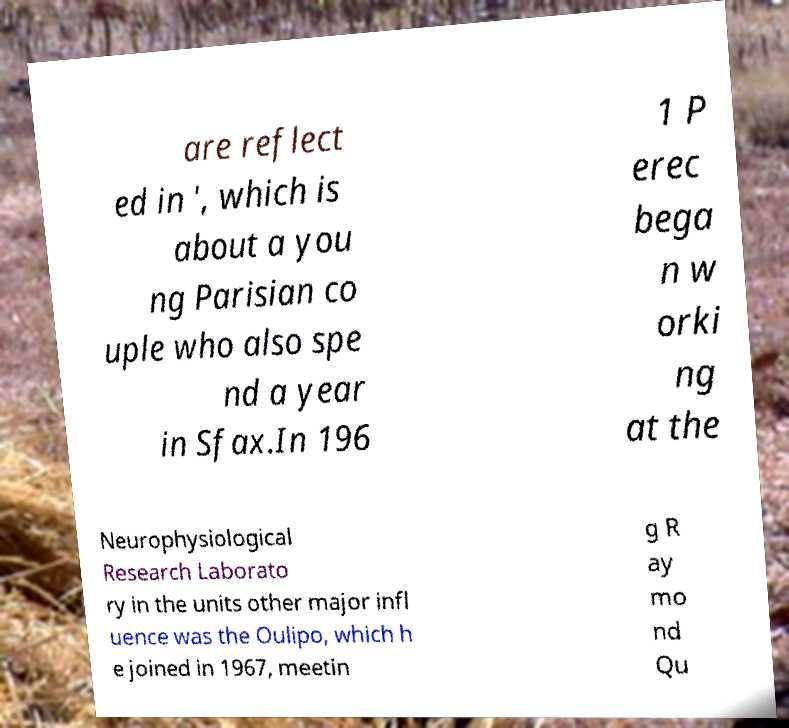Could you extract and type out the text from this image? are reflect ed in ', which is about a you ng Parisian co uple who also spe nd a year in Sfax.In 196 1 P erec bega n w orki ng at the Neurophysiological Research Laborato ry in the units other major infl uence was the Oulipo, which h e joined in 1967, meetin g R ay mo nd Qu 